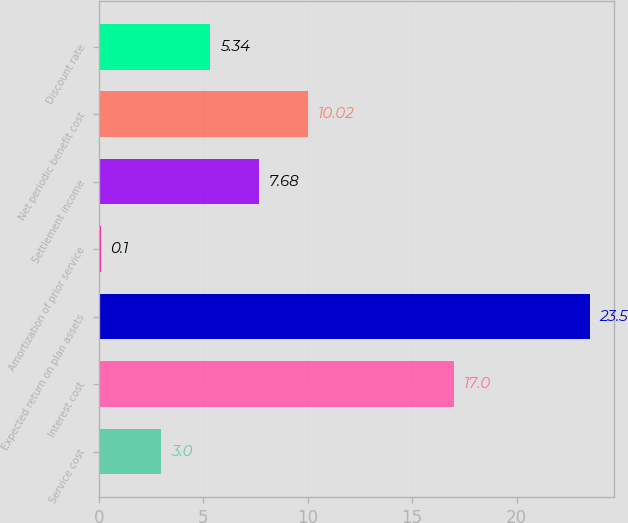Convert chart to OTSL. <chart><loc_0><loc_0><loc_500><loc_500><bar_chart><fcel>Service cost<fcel>Interest cost<fcel>Expected return on plan assets<fcel>Amortization of prior service<fcel>Settlement income<fcel>Net periodic benefit cost<fcel>Discount rate<nl><fcel>3<fcel>17<fcel>23.5<fcel>0.1<fcel>7.68<fcel>10.02<fcel>5.34<nl></chart> 